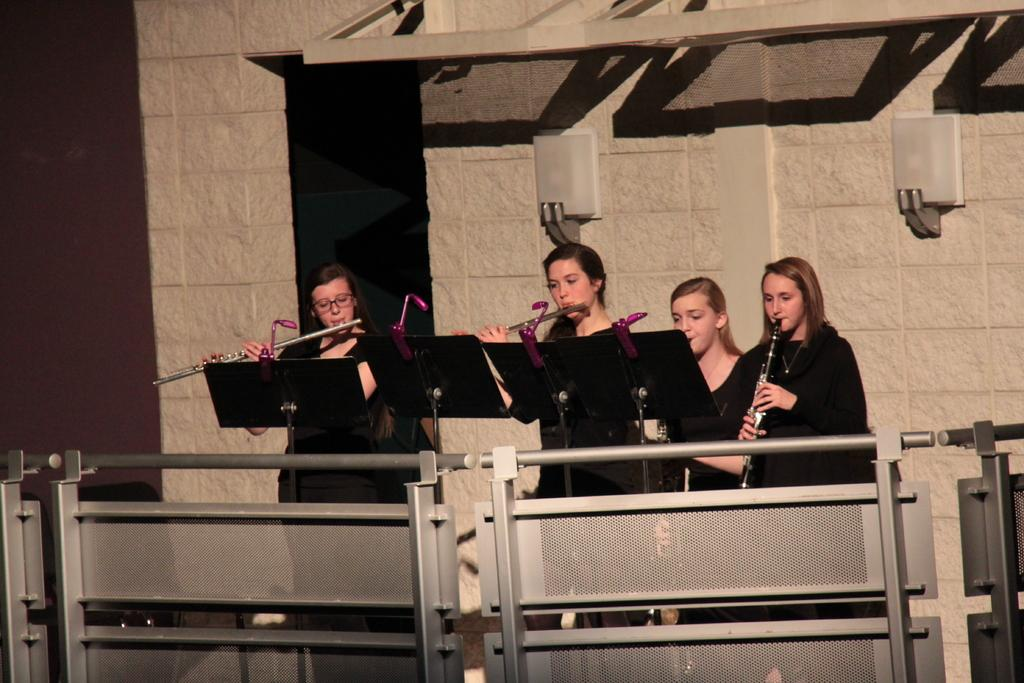What are the women in the image doing? The women in the image are playing musical instruments. What can be seen in the background of the image? There is a wall in the background of the image. What is located at the front of the image? There is a fencing at the front of the image. What type of government is depicted in the image? There is no depiction of a government in the image; it features women playing musical instruments. What kind of soda can be seen being consumed by the women in the image? There is no soda present in the image; it only shows women playing musical instruments. 